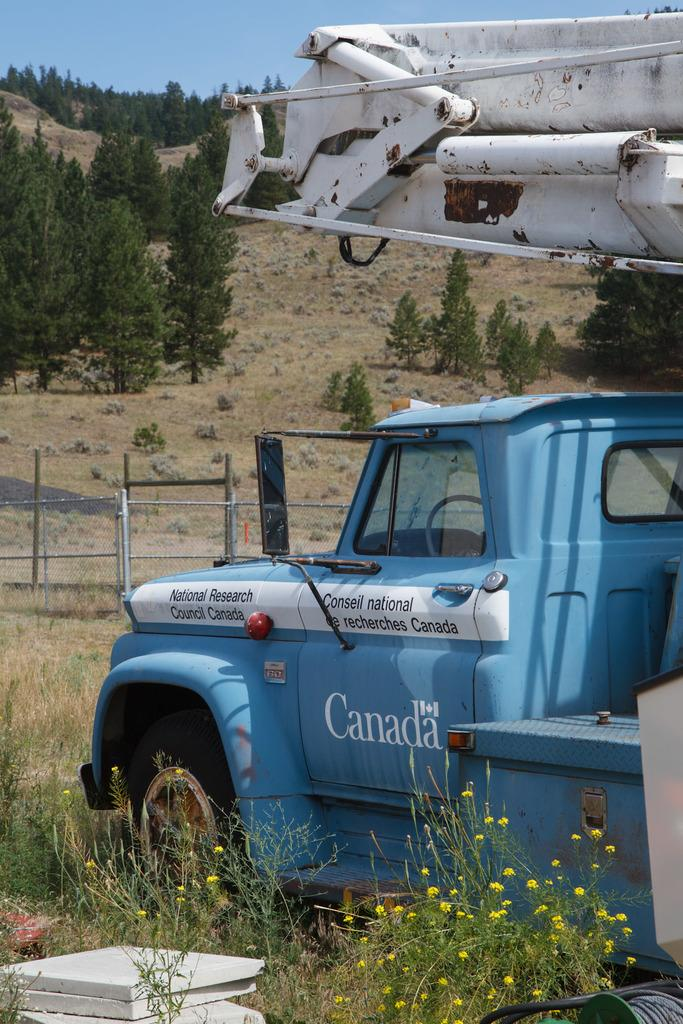What is the main object on the ground in the image? There is a vehicle on the ground in the image. What type of surface is the vehicle on? Stone tiles are visible in the image. What type of vegetation can be seen in the image? There are plants with flowers in the image. What architectural feature is visible in the background of the image? There is a fence in the background of the image. What natural elements are visible in the background of the image? Trees and the sky are visible in the background of the image. What type of brush is used to paint the morning sky in the image? There is no brush or painting in the image; the sky is a natural element visible in the background. 